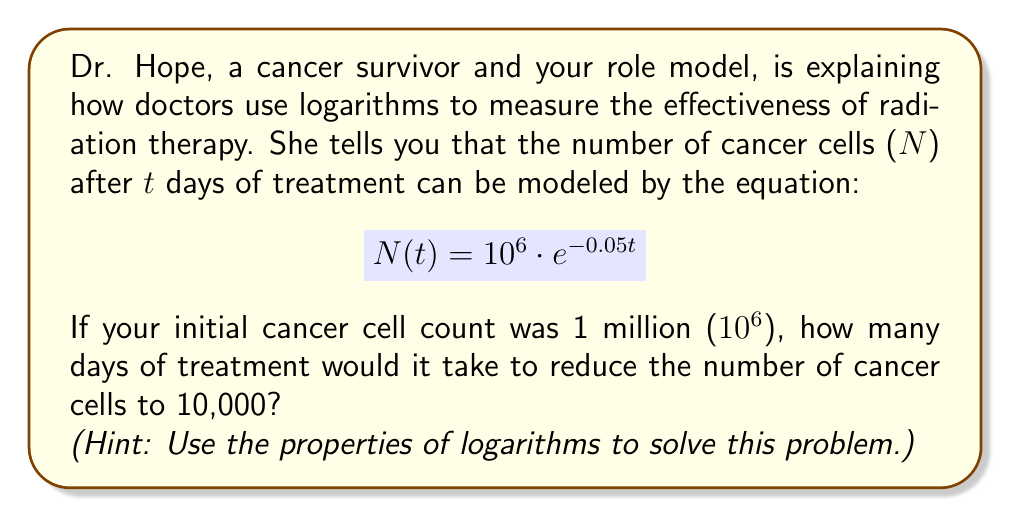What is the answer to this math problem? Let's approach this step-by-step:

1) We start with the equation: $N(t) = 10^6 \cdot e^{-0.05t}$

2) We want to find t when N(t) = 10,000 = $10^4$

3) Let's substitute this into our equation:
   $10^4 = 10^6 \cdot e^{-0.05t}$

4) Divide both sides by $10^6$:
   $\frac{10^4}{10^6} = e^{-0.05t}$

5) Simplify the left side:
   $10^{-2} = e^{-0.05t}$

6) Now, let's take the natural log of both sides:
   $\ln(10^{-2}) = \ln(e^{-0.05t})$

7) Using the property of logarithms that $\ln(e^x) = x$, we get:
   $\ln(10^{-2}) = -0.05t$

8) Using the property $\ln(a^b) = b\ln(a)$, the left side becomes:
   $-2\ln(10) = -0.05t$

9) Now, solve for t:
   $t = \frac{2\ln(10)}{0.05}$

10) Calculate this value:
    $t = \frac{2 \cdot 2.30258509}{0.05} \approx 92.10$

Therefore, it would take approximately 92.10 days of treatment to reduce the number of cancer cells from 1 million to 10,000.
Answer: Approximately 92.10 days 